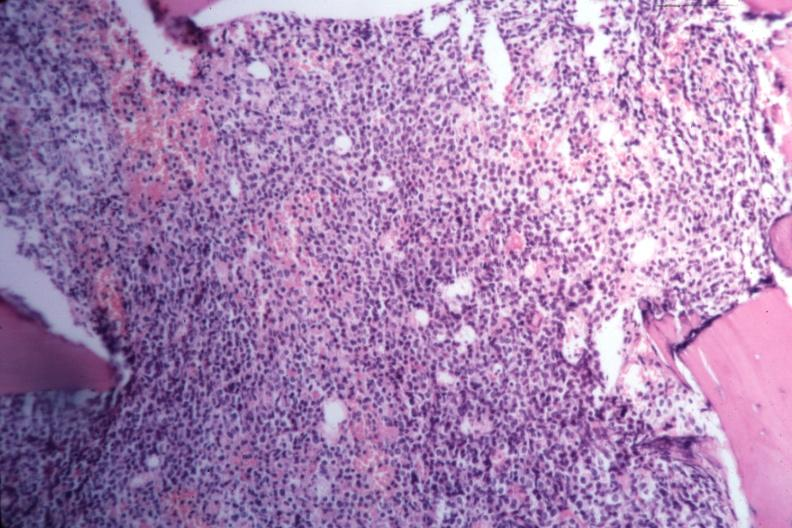s hematologic present?
Answer the question using a single word or phrase. Yes 